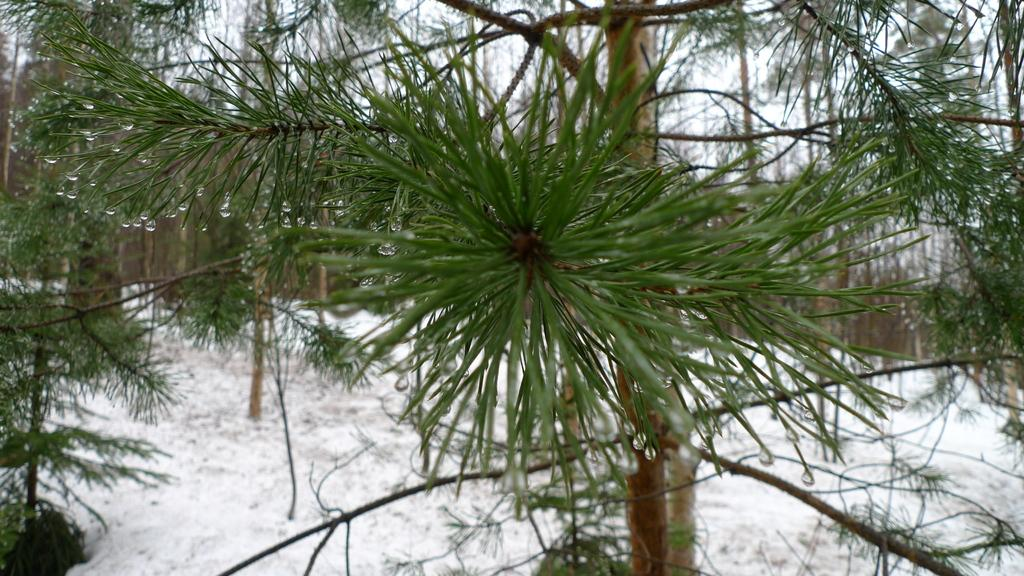What type of vegetation is present in the image? There are many trees in the image. What is covering the ground in the image? There is snow visible on the ground. What part of the natural environment is visible in the image? The sky is visible in the image. What type of quartz can be seen in the image? There is no quartz present in the image. What kind of toy is being played with in the image? There are no toys present in the image. 